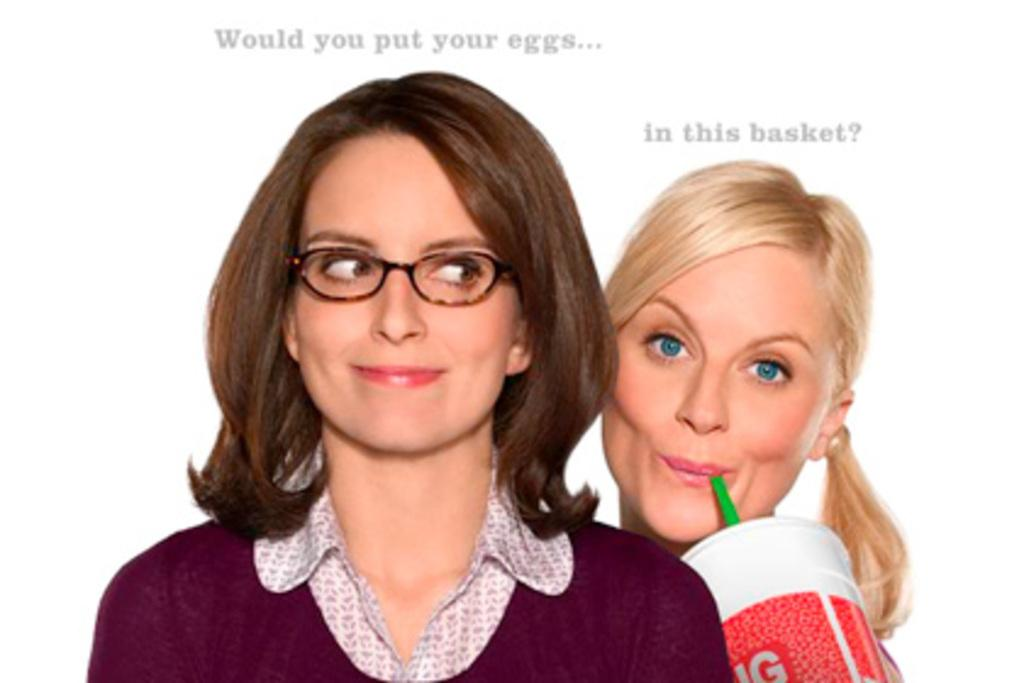How many people are in the image? There are two persons in the image. What expressions do the people have? Both persons are smiling. Can you describe any accessories worn by the people? One person is wearing spectacles. What is the person holding a straw and a cup doing? The person is likely drinking from the cup. Are there any visible imperfections on the image? Yes, there are watermarks on the image. What type of soap is being offered by the person in the image? There is no soap present in the image, nor is anyone offering anything. 